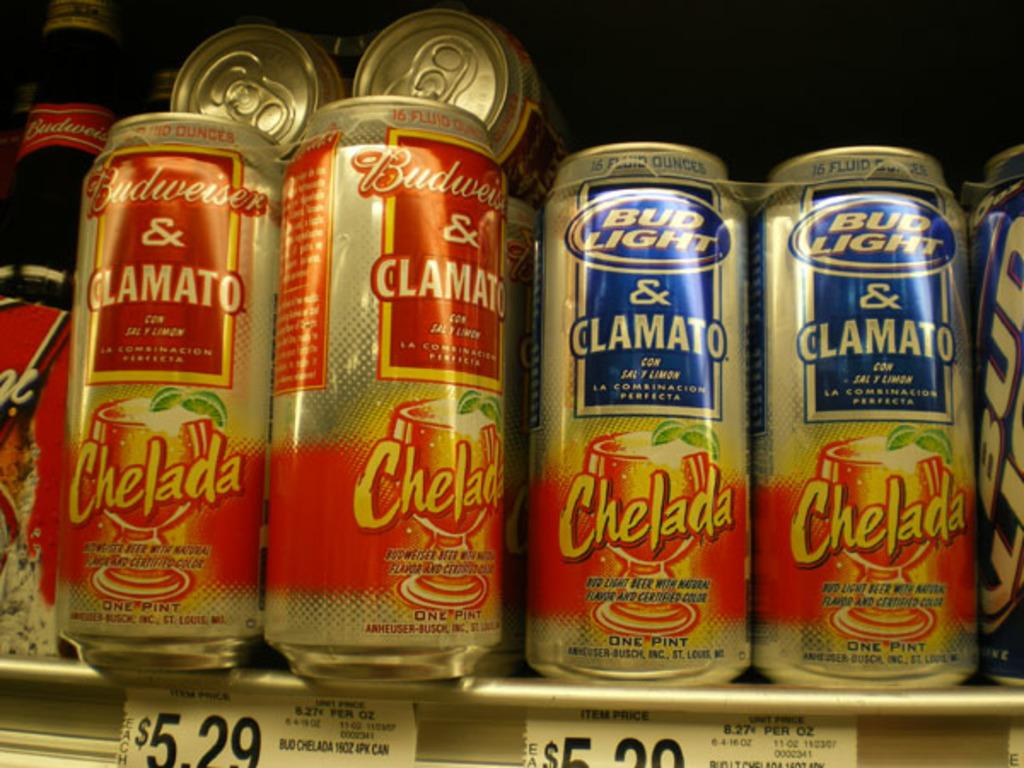Provide a one-sentence caption for the provided image. Cans of Bud light and Budweiser with Spanish writing on them sit on a shelf. 